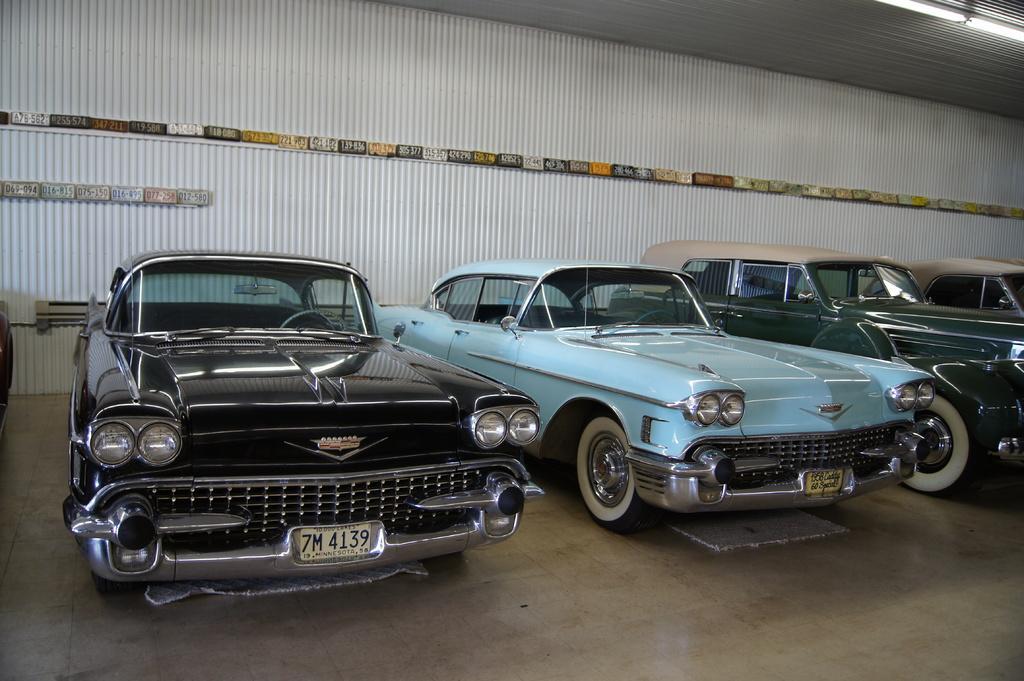Describe this image in one or two sentences. In this picture I can see the vehicles on the surface. I can see light arrangements on the roof. 